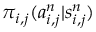Convert formula to latex. <formula><loc_0><loc_0><loc_500><loc_500>\pi _ { i , j } ( a _ { i , j } ^ { n } | s _ { i , j } ^ { n } )</formula> 